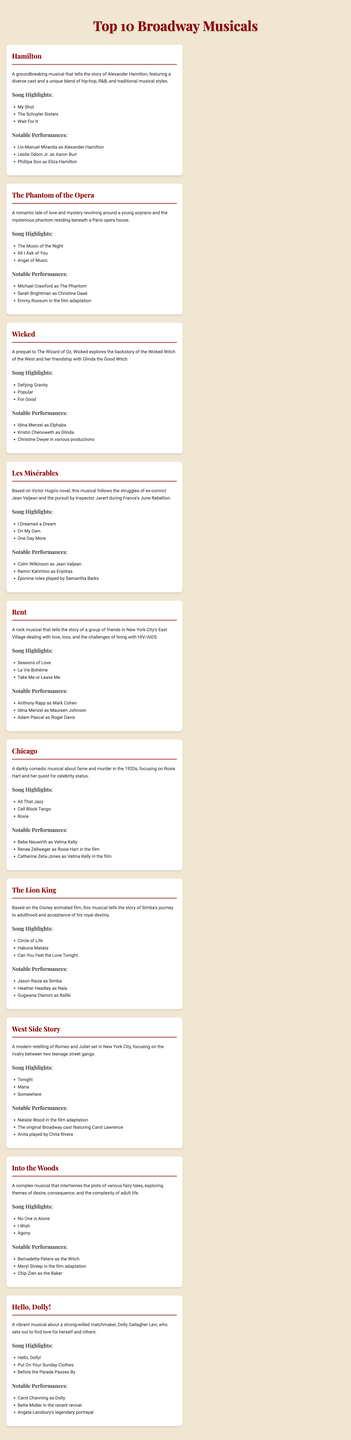What is the title of the musical that tells the story of Alexander Hamilton? The title is specifically mentioned in the document under the "Top 10 Broadway Musicals" section.
Answer: Hamilton Which song is highlighted from "The Phantom of the Opera"? The document contains a list of song highlights under each musical, including this specific one.
Answer: The Music of the Night Who played Elphaba in "Wicked"? Notable performances include cast members listed for each musical, which directly answers this question.
Answer: Idina Menzel What year did "Les Misérables" first premiere on Broadway? The manual focuses on overviews and cast, and while it may suggest popularity, it does not include specific years of premiere.
Answer: Not mentioned Name one song from "Chicago." The document provides song highlights for each musical, making it simple to extract this information.
Answer: All That Jazz Which character does Bernadette Peters play in "Into the Woods"? The document lists notable performances, indicating the characters played by specific actors.
Answer: The Witch What is the main theme of "Rent"? The summary of each musical in the document provides insight into their themes.
Answer: Love and loss Who had a notable performance as Dolly in "Hello, Dolly!"? The document lists notable performances for each musical, thus this is easy to find.
Answer: Carol Channing Name the musical that features the song "Defying Gravity." Each musical's highlights include specific songs, allowing for straightforward answers.
Answer: Wicked 